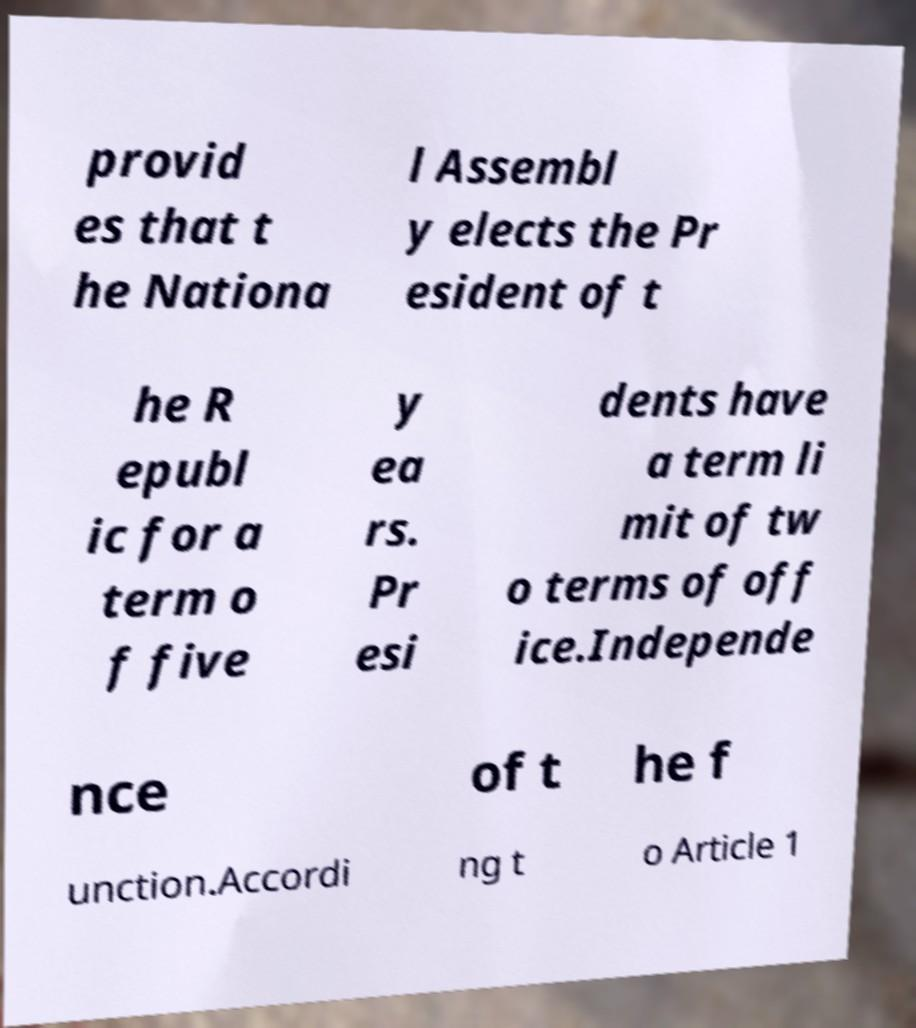There's text embedded in this image that I need extracted. Can you transcribe it verbatim? provid es that t he Nationa l Assembl y elects the Pr esident of t he R epubl ic for a term o f five y ea rs. Pr esi dents have a term li mit of tw o terms of off ice.Independe nce of t he f unction.Accordi ng t o Article 1 